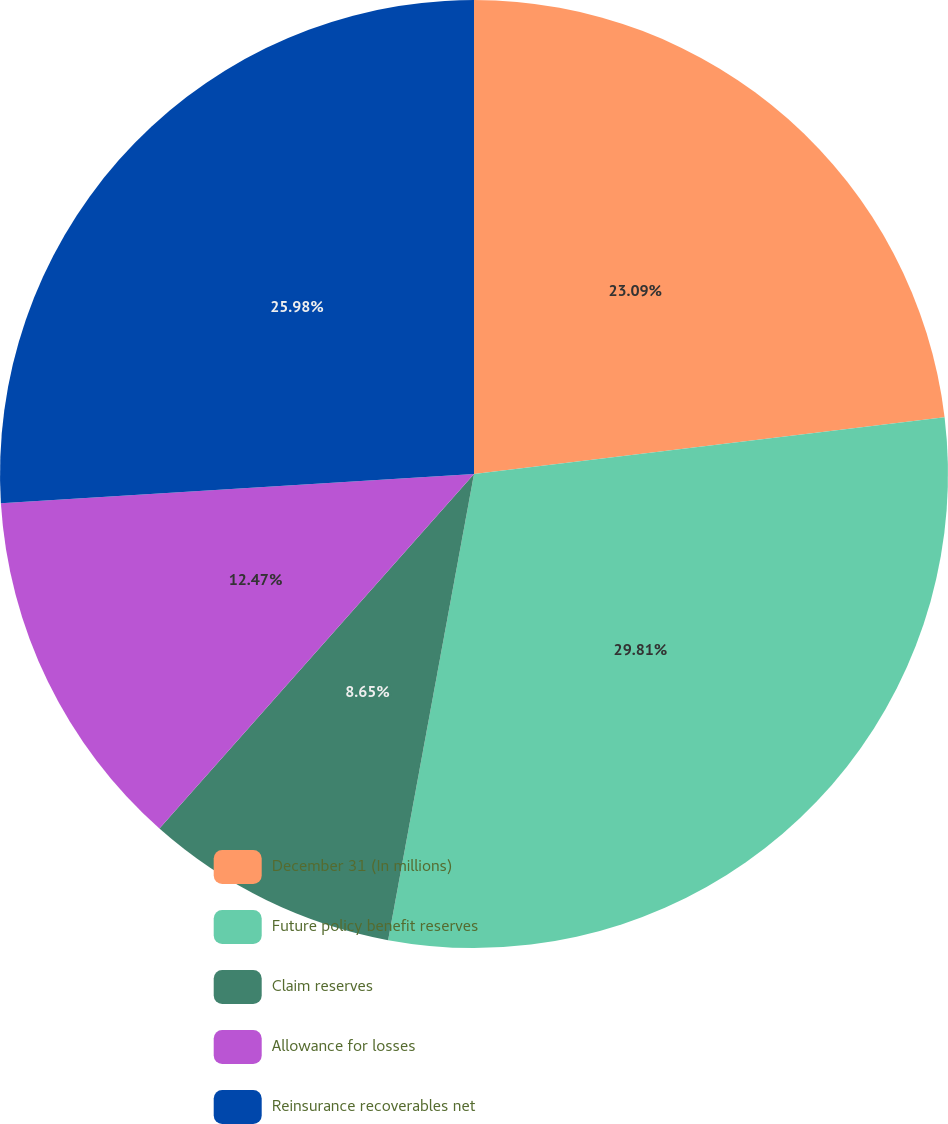Convert chart to OTSL. <chart><loc_0><loc_0><loc_500><loc_500><pie_chart><fcel>December 31 (In millions)<fcel>Future policy benefit reserves<fcel>Claim reserves<fcel>Allowance for losses<fcel>Reinsurance recoverables net<nl><fcel>23.09%<fcel>29.81%<fcel>8.65%<fcel>12.47%<fcel>25.98%<nl></chart> 